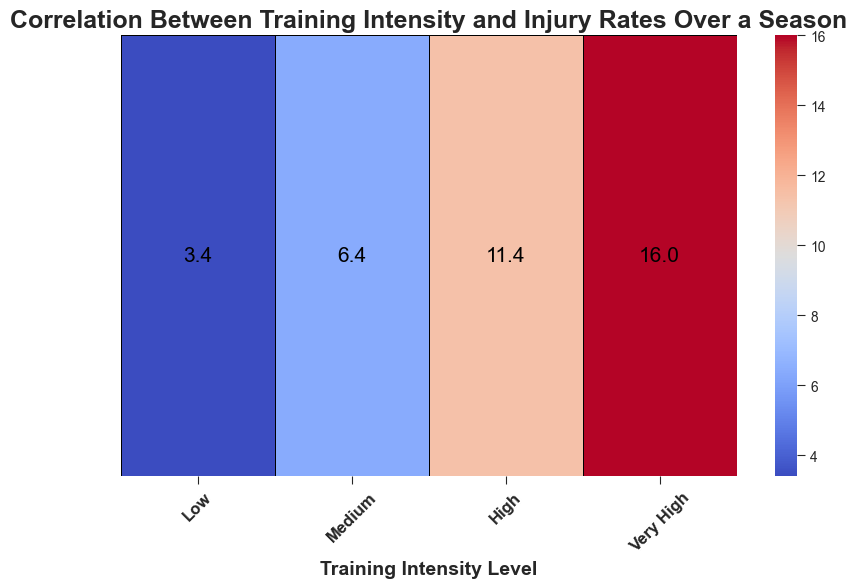What's the average injury rate for 'Medium' training intensity? The average injury rate for 'Medium' training intensity can be found directly in the heatmap. Look at the value corresponding to 'Medium' in the heatmap.
Answer: 6.4 Which training intensity level has the highest average injury rate? To determine this, look at the numerical values in each cell of the heatmap. The highest value indicates the training intensity level with the highest average injury rate.
Answer: Very High Compare the average injury rates between 'Low' and 'High' training intensities. Which is higher? Find the average injury rates for both 'Low' and 'High' training intensities from the heatmap. Then, compare the two values to see which one is higher.
Answer: High By how much does the average injury rate increase when moving from 'Low' to 'Very High' training intensity? Find the average injury rates for 'Low' and 'Very High' training intensity levels from the heatmap. Subtract the average injury rate of 'Low' from 'Very High' to determine the increase.
Answer: 12.4 Is the injury rate for 'High' training intensity more than twice the rate for 'Low' training intensity? First, find the average injury rate for 'Low' training intensity, then multiply this value by 2. Compare this result with the average injury rate for 'High' training intensity.
Answer: Yes What is the color representing the highest injury rate? Look at the heatmap to see the color in the cell with the highest injury rate. Note this color.
Answer: Dark red Does 'Medium' training intensity have a higher or lower average injury rate than 'High'? Compare the average injury rates of 'Medium' and 'High' as shown on the heatmap. Determine which is higher or lower.
Answer: Lower What is the difference in average injury rates between 'Medium' and 'Very High' training intensities? Find the numerical differences by subtracting the average injury rate of 'Medium' training intensity from the 'Very High' training intensity as shown in the heatmap.
Answer: 9.6 Which training intensity level shows the least average injury rate? Identify the smallest numeric value displayed in the heatmap, which corresponds to the lowest average injury rate, and note the associated training intensity level.
Answer: Low 